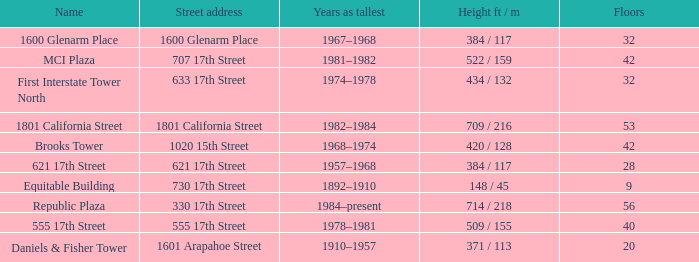What is the height of the building with 40 floors? 509 / 155. 